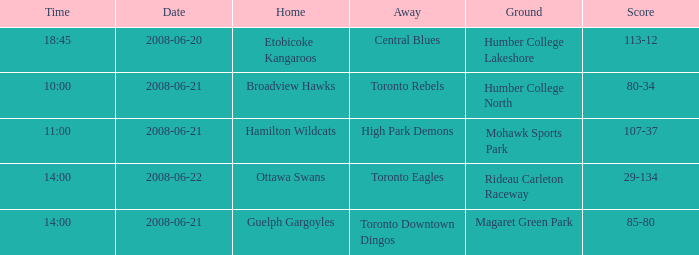Could you parse the entire table as a dict? {'header': ['Time', 'Date', 'Home', 'Away', 'Ground', 'Score'], 'rows': [['18:45', '2008-06-20', 'Etobicoke Kangaroos', 'Central Blues', 'Humber College Lakeshore', '113-12'], ['10:00', '2008-06-21', 'Broadview Hawks', 'Toronto Rebels', 'Humber College North', '80-34'], ['11:00', '2008-06-21', 'Hamilton Wildcats', 'High Park Demons', 'Mohawk Sports Park', '107-37'], ['14:00', '2008-06-22', 'Ottawa Swans', 'Toronto Eagles', 'Rideau Carleton Raceway', '29-134'], ['14:00', '2008-06-21', 'Guelph Gargoyles', 'Toronto Downtown Dingos', 'Magaret Green Park', '85-80']]} What is the Time with a Score that is 80-34? 10:00. 